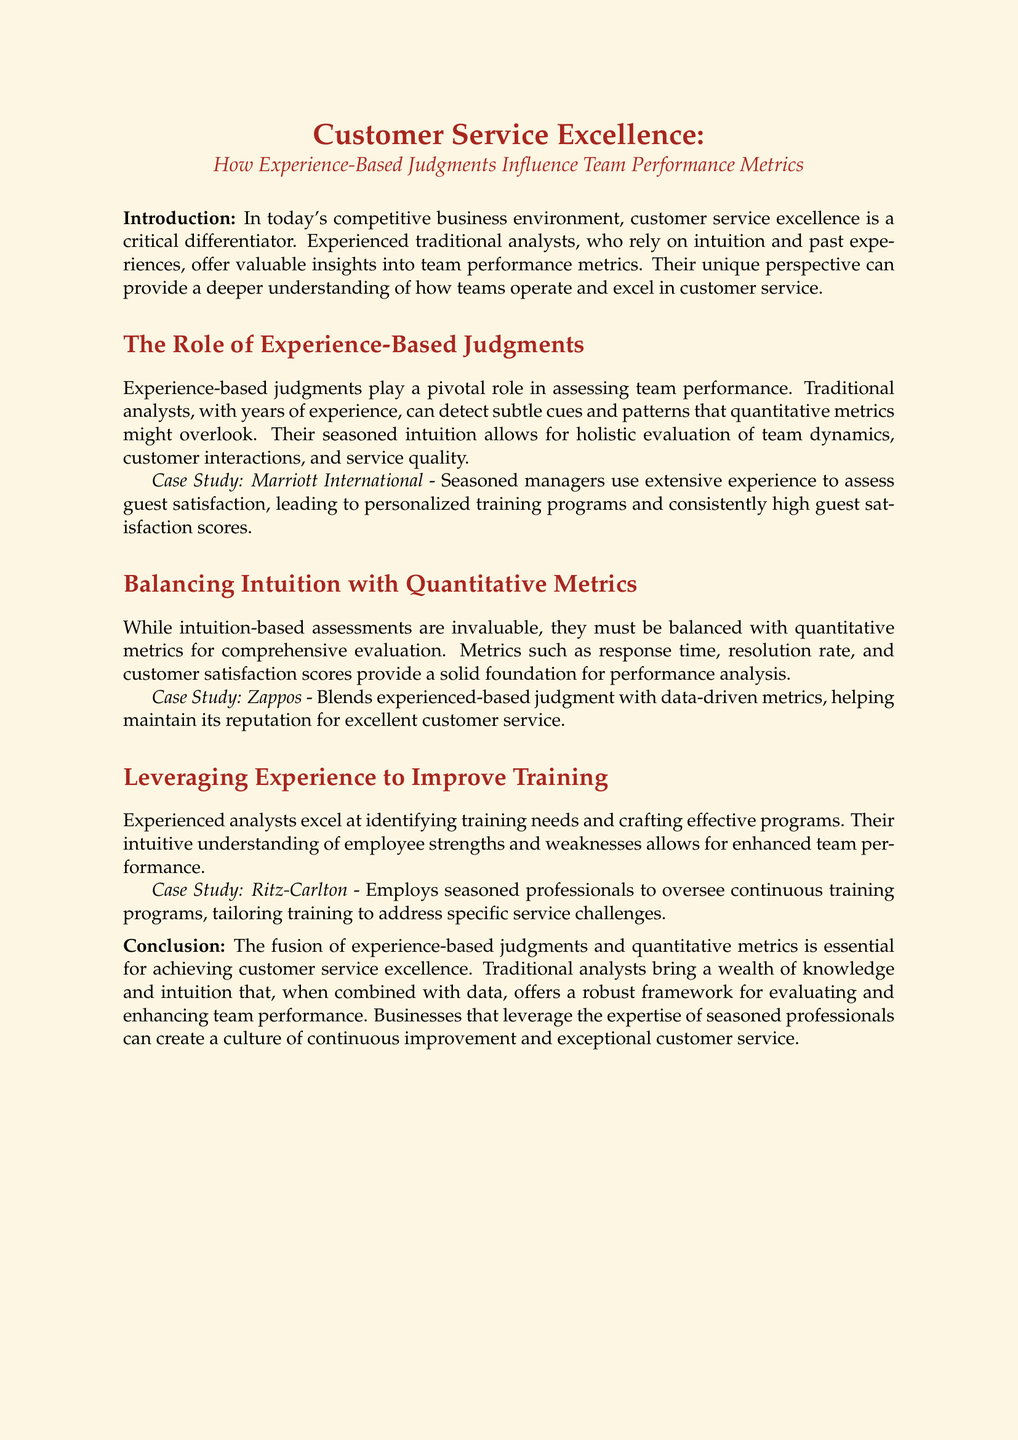what is the title of the document? The title is stated prominently in the header section of the document.
Answer: Customer Service Excellence: How Experience-Based Judgments Influence Team Performance Metrics who is cited as a case study for using experience-based judgments in customer service? The document mentions specific companies in the context of experience-based judgments in customer service.
Answer: Marriott International what metrics are suggested to balance intuition-based assessments? The document lists specific metrics to provide a solid foundation for performance analysis.
Answer: Response time, resolution rate, and customer satisfaction scores which company is noted for blending experienced-based judgment with data-driven metrics? The document highlights a particular company as an example of this blending approach.
Answer: Zappos how does Ritz-Carlton utilize seasoned professionals? The document mentions the role of experienced professionals in a specific context related to training.
Answer: Oversee continuous training programs what is the main conclusion of the whitepaper? The conclusion summarizes the overall findings of the document regarding a specific topic.
Answer: The fusion of experience-based judgments and quantitative metrics is essential for achieving customer service excellence 